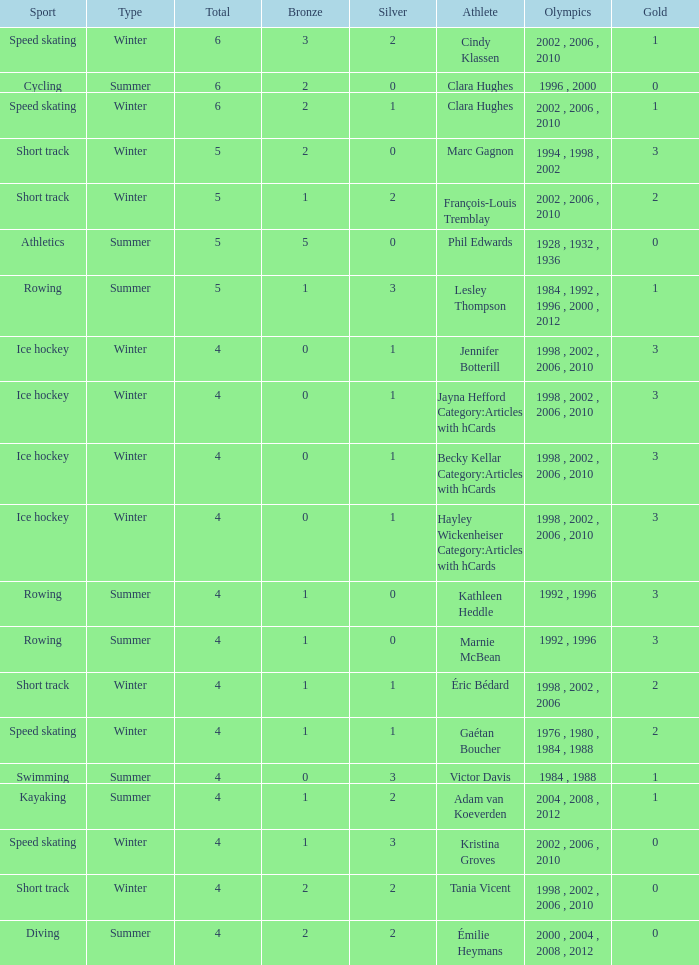What is the lowest number of bronze a short track athlete with 0 gold medals has? 2.0. 